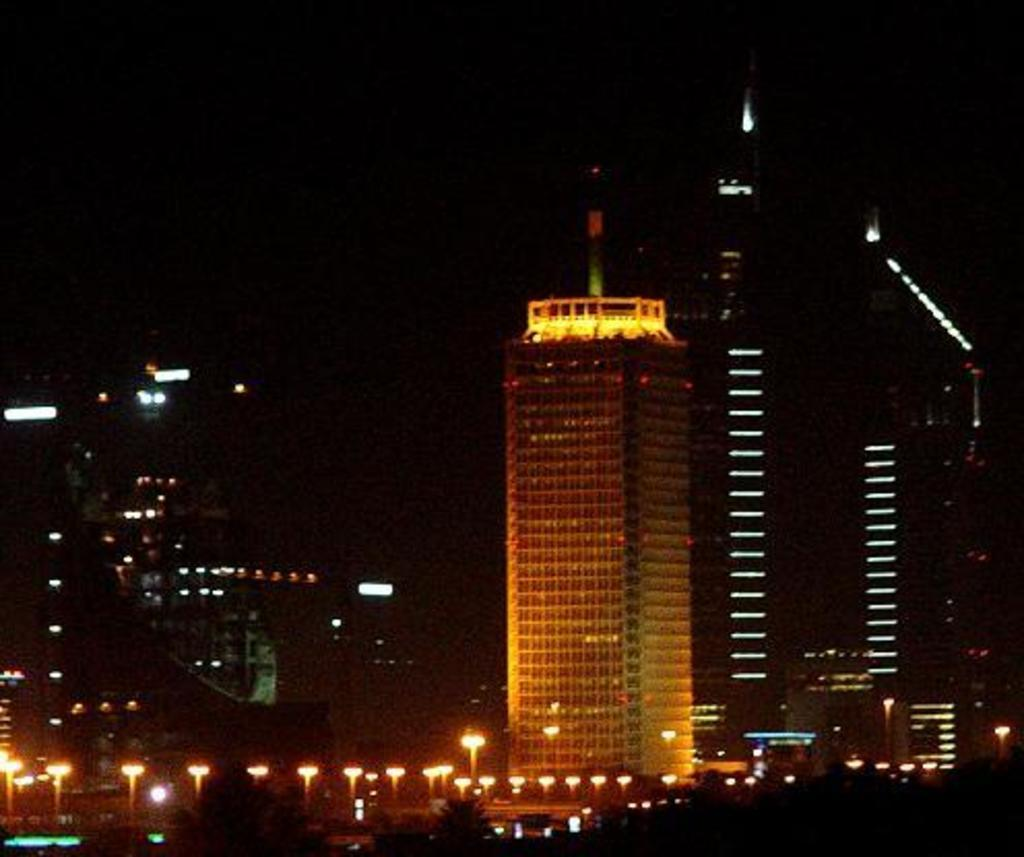What is located at the bottom of the image? There are trees and lights at the bottom of the image. What can be seen in the middle of the image? There are big buildings in the middle of the image. What time of day is depicted in the image? The image is set at night. Can you tell me what your dad is saying in the image? There is no person, including a dad, present in the image. Is there a cellar visible in the image? There is no mention of a cellar in the provided facts, and therefore it cannot be confirmed or denied. 